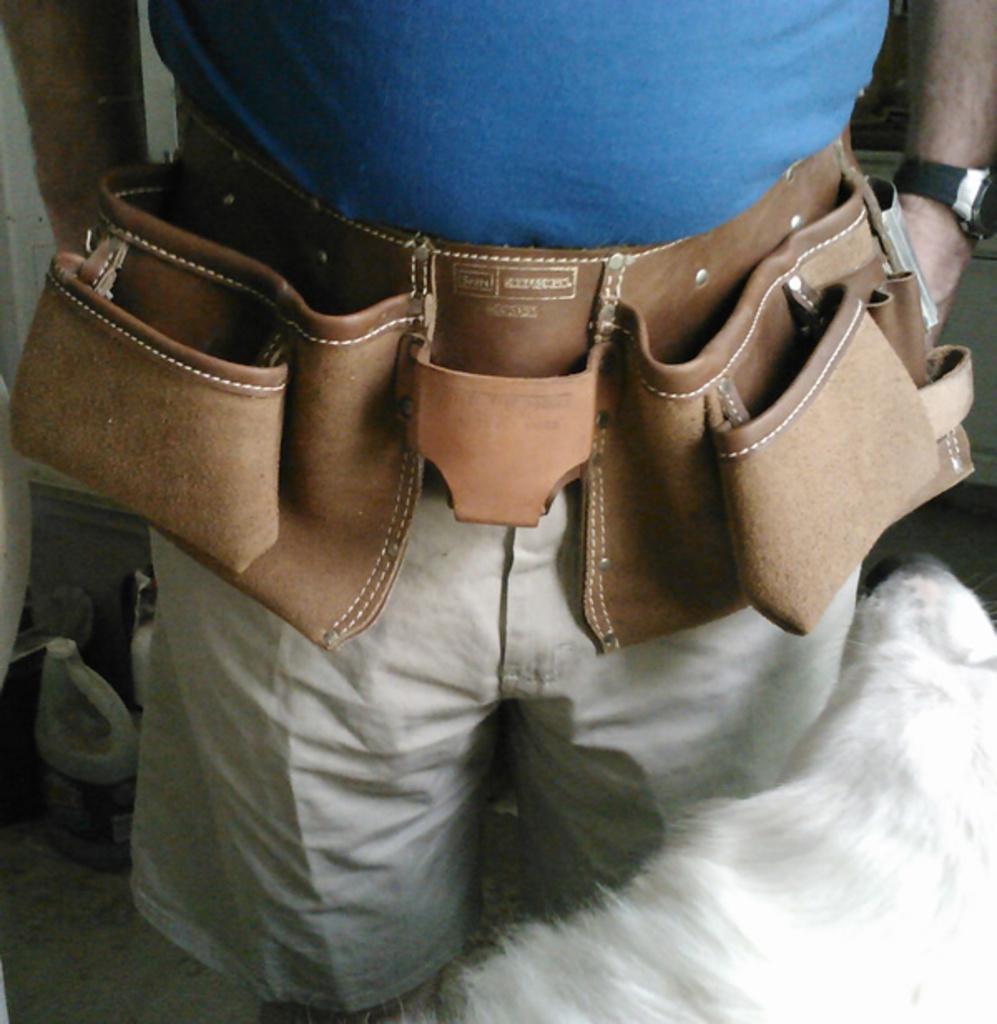Could you give a brief overview of what you see in this image? In this picture I can see a person is wearing blue color top, a tool belt and shorts. Here I can see a watch on the hand. In the background I can see some other objects. 